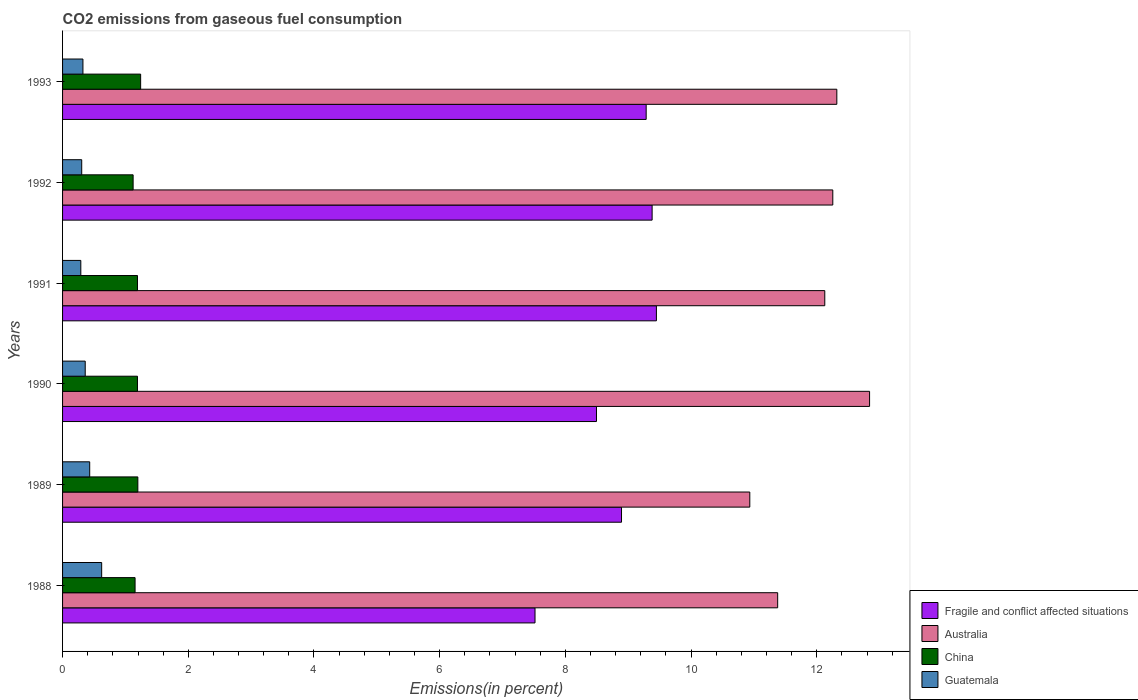How many groups of bars are there?
Provide a short and direct response. 6. Are the number of bars per tick equal to the number of legend labels?
Keep it short and to the point. Yes. How many bars are there on the 3rd tick from the top?
Ensure brevity in your answer.  4. In how many cases, is the number of bars for a given year not equal to the number of legend labels?
Ensure brevity in your answer.  0. What is the total CO2 emitted in Fragile and conflict affected situations in 1991?
Keep it short and to the point. 9.45. Across all years, what is the maximum total CO2 emitted in Guatemala?
Ensure brevity in your answer.  0.62. Across all years, what is the minimum total CO2 emitted in Australia?
Keep it short and to the point. 10.93. In which year was the total CO2 emitted in Guatemala maximum?
Ensure brevity in your answer.  1988. What is the total total CO2 emitted in Fragile and conflict affected situations in the graph?
Provide a short and direct response. 53.02. What is the difference between the total CO2 emitted in China in 1989 and that in 1993?
Give a very brief answer. -0.04. What is the difference between the total CO2 emitted in Australia in 1988 and the total CO2 emitted in Guatemala in 1989?
Make the answer very short. 10.95. What is the average total CO2 emitted in Guatemala per year?
Provide a short and direct response. 0.39. In the year 1989, what is the difference between the total CO2 emitted in China and total CO2 emitted in Guatemala?
Keep it short and to the point. 0.77. What is the ratio of the total CO2 emitted in Fragile and conflict affected situations in 1989 to that in 1991?
Give a very brief answer. 0.94. Is the difference between the total CO2 emitted in China in 1991 and 1992 greater than the difference between the total CO2 emitted in Guatemala in 1991 and 1992?
Offer a very short reply. Yes. What is the difference between the highest and the second highest total CO2 emitted in Fragile and conflict affected situations?
Provide a short and direct response. 0.07. What is the difference between the highest and the lowest total CO2 emitted in China?
Keep it short and to the point. 0.12. In how many years, is the total CO2 emitted in Fragile and conflict affected situations greater than the average total CO2 emitted in Fragile and conflict affected situations taken over all years?
Ensure brevity in your answer.  4. Is it the case that in every year, the sum of the total CO2 emitted in Australia and total CO2 emitted in Guatemala is greater than the sum of total CO2 emitted in Fragile and conflict affected situations and total CO2 emitted in China?
Provide a succinct answer. Yes. What does the 4th bar from the top in 1988 represents?
Give a very brief answer. Fragile and conflict affected situations. What does the 4th bar from the bottom in 1988 represents?
Make the answer very short. Guatemala. Is it the case that in every year, the sum of the total CO2 emitted in Fragile and conflict affected situations and total CO2 emitted in China is greater than the total CO2 emitted in Guatemala?
Provide a succinct answer. Yes. Are all the bars in the graph horizontal?
Your answer should be very brief. Yes. How many years are there in the graph?
Provide a succinct answer. 6. What is the difference between two consecutive major ticks on the X-axis?
Give a very brief answer. 2. Does the graph contain any zero values?
Keep it short and to the point. No. Does the graph contain grids?
Offer a very short reply. No. How many legend labels are there?
Provide a short and direct response. 4. How are the legend labels stacked?
Ensure brevity in your answer.  Vertical. What is the title of the graph?
Ensure brevity in your answer.  CO2 emissions from gaseous fuel consumption. What is the label or title of the X-axis?
Keep it short and to the point. Emissions(in percent). What is the Emissions(in percent) of Fragile and conflict affected situations in 1988?
Offer a very short reply. 7.52. What is the Emissions(in percent) in Australia in 1988?
Make the answer very short. 11.38. What is the Emissions(in percent) in China in 1988?
Offer a terse response. 1.15. What is the Emissions(in percent) of Guatemala in 1988?
Keep it short and to the point. 0.62. What is the Emissions(in percent) in Fragile and conflict affected situations in 1989?
Offer a very short reply. 8.89. What is the Emissions(in percent) in Australia in 1989?
Your answer should be compact. 10.93. What is the Emissions(in percent) of China in 1989?
Ensure brevity in your answer.  1.2. What is the Emissions(in percent) of Guatemala in 1989?
Keep it short and to the point. 0.43. What is the Emissions(in percent) of Fragile and conflict affected situations in 1990?
Make the answer very short. 8.49. What is the Emissions(in percent) of Australia in 1990?
Make the answer very short. 12.84. What is the Emissions(in percent) of China in 1990?
Your answer should be very brief. 1.19. What is the Emissions(in percent) of Guatemala in 1990?
Provide a short and direct response. 0.36. What is the Emissions(in percent) in Fragile and conflict affected situations in 1991?
Ensure brevity in your answer.  9.45. What is the Emissions(in percent) of Australia in 1991?
Keep it short and to the point. 12.13. What is the Emissions(in percent) in China in 1991?
Provide a short and direct response. 1.19. What is the Emissions(in percent) of Guatemala in 1991?
Keep it short and to the point. 0.29. What is the Emissions(in percent) in Fragile and conflict affected situations in 1992?
Offer a very short reply. 9.38. What is the Emissions(in percent) in Australia in 1992?
Offer a very short reply. 12.25. What is the Emissions(in percent) of China in 1992?
Your response must be concise. 1.12. What is the Emissions(in percent) in Guatemala in 1992?
Make the answer very short. 0.3. What is the Emissions(in percent) in Fragile and conflict affected situations in 1993?
Provide a short and direct response. 9.28. What is the Emissions(in percent) in Australia in 1993?
Make the answer very short. 12.32. What is the Emissions(in percent) in China in 1993?
Your answer should be compact. 1.24. What is the Emissions(in percent) in Guatemala in 1993?
Ensure brevity in your answer.  0.32. Across all years, what is the maximum Emissions(in percent) of Fragile and conflict affected situations?
Make the answer very short. 9.45. Across all years, what is the maximum Emissions(in percent) in Australia?
Your answer should be compact. 12.84. Across all years, what is the maximum Emissions(in percent) in China?
Make the answer very short. 1.24. Across all years, what is the maximum Emissions(in percent) of Guatemala?
Your answer should be very brief. 0.62. Across all years, what is the minimum Emissions(in percent) of Fragile and conflict affected situations?
Offer a terse response. 7.52. Across all years, what is the minimum Emissions(in percent) of Australia?
Offer a very short reply. 10.93. Across all years, what is the minimum Emissions(in percent) of China?
Make the answer very short. 1.12. Across all years, what is the minimum Emissions(in percent) of Guatemala?
Keep it short and to the point. 0.29. What is the total Emissions(in percent) of Fragile and conflict affected situations in the graph?
Provide a succinct answer. 53.02. What is the total Emissions(in percent) of Australia in the graph?
Offer a terse response. 71.85. What is the total Emissions(in percent) of China in the graph?
Your answer should be compact. 7.1. What is the total Emissions(in percent) in Guatemala in the graph?
Provide a succinct answer. 2.33. What is the difference between the Emissions(in percent) in Fragile and conflict affected situations in 1988 and that in 1989?
Provide a short and direct response. -1.38. What is the difference between the Emissions(in percent) in Australia in 1988 and that in 1989?
Make the answer very short. 0.44. What is the difference between the Emissions(in percent) in China in 1988 and that in 1989?
Your answer should be compact. -0.04. What is the difference between the Emissions(in percent) in Guatemala in 1988 and that in 1989?
Give a very brief answer. 0.19. What is the difference between the Emissions(in percent) of Fragile and conflict affected situations in 1988 and that in 1990?
Offer a terse response. -0.98. What is the difference between the Emissions(in percent) in Australia in 1988 and that in 1990?
Your answer should be very brief. -1.46. What is the difference between the Emissions(in percent) in China in 1988 and that in 1990?
Offer a very short reply. -0.04. What is the difference between the Emissions(in percent) of Guatemala in 1988 and that in 1990?
Provide a short and direct response. 0.26. What is the difference between the Emissions(in percent) of Fragile and conflict affected situations in 1988 and that in 1991?
Your response must be concise. -1.93. What is the difference between the Emissions(in percent) in Australia in 1988 and that in 1991?
Make the answer very short. -0.75. What is the difference between the Emissions(in percent) in China in 1988 and that in 1991?
Give a very brief answer. -0.04. What is the difference between the Emissions(in percent) of Guatemala in 1988 and that in 1991?
Provide a short and direct response. 0.33. What is the difference between the Emissions(in percent) in Fragile and conflict affected situations in 1988 and that in 1992?
Offer a very short reply. -1.86. What is the difference between the Emissions(in percent) in Australia in 1988 and that in 1992?
Your response must be concise. -0.88. What is the difference between the Emissions(in percent) in China in 1988 and that in 1992?
Give a very brief answer. 0.03. What is the difference between the Emissions(in percent) of Guatemala in 1988 and that in 1992?
Provide a short and direct response. 0.32. What is the difference between the Emissions(in percent) in Fragile and conflict affected situations in 1988 and that in 1993?
Your answer should be very brief. -1.77. What is the difference between the Emissions(in percent) in Australia in 1988 and that in 1993?
Provide a succinct answer. -0.94. What is the difference between the Emissions(in percent) in China in 1988 and that in 1993?
Your answer should be compact. -0.09. What is the difference between the Emissions(in percent) of Guatemala in 1988 and that in 1993?
Provide a succinct answer. 0.3. What is the difference between the Emissions(in percent) of Fragile and conflict affected situations in 1989 and that in 1990?
Your answer should be compact. 0.4. What is the difference between the Emissions(in percent) in Australia in 1989 and that in 1990?
Your answer should be very brief. -1.91. What is the difference between the Emissions(in percent) of China in 1989 and that in 1990?
Offer a very short reply. 0.01. What is the difference between the Emissions(in percent) of Guatemala in 1989 and that in 1990?
Your response must be concise. 0.07. What is the difference between the Emissions(in percent) in Fragile and conflict affected situations in 1989 and that in 1991?
Your answer should be very brief. -0.56. What is the difference between the Emissions(in percent) in Australia in 1989 and that in 1991?
Your response must be concise. -1.19. What is the difference between the Emissions(in percent) in China in 1989 and that in 1991?
Your answer should be very brief. 0.01. What is the difference between the Emissions(in percent) in Guatemala in 1989 and that in 1991?
Your answer should be compact. 0.14. What is the difference between the Emissions(in percent) in Fragile and conflict affected situations in 1989 and that in 1992?
Keep it short and to the point. -0.49. What is the difference between the Emissions(in percent) in Australia in 1989 and that in 1992?
Give a very brief answer. -1.32. What is the difference between the Emissions(in percent) of China in 1989 and that in 1992?
Your response must be concise. 0.07. What is the difference between the Emissions(in percent) in Guatemala in 1989 and that in 1992?
Your answer should be very brief. 0.13. What is the difference between the Emissions(in percent) of Fragile and conflict affected situations in 1989 and that in 1993?
Offer a terse response. -0.39. What is the difference between the Emissions(in percent) of Australia in 1989 and that in 1993?
Your answer should be very brief. -1.38. What is the difference between the Emissions(in percent) of China in 1989 and that in 1993?
Give a very brief answer. -0.04. What is the difference between the Emissions(in percent) in Guatemala in 1989 and that in 1993?
Your answer should be very brief. 0.11. What is the difference between the Emissions(in percent) of Fragile and conflict affected situations in 1990 and that in 1991?
Provide a short and direct response. -0.95. What is the difference between the Emissions(in percent) of Australia in 1990 and that in 1991?
Ensure brevity in your answer.  0.71. What is the difference between the Emissions(in percent) in China in 1990 and that in 1991?
Your answer should be compact. -0. What is the difference between the Emissions(in percent) in Guatemala in 1990 and that in 1991?
Make the answer very short. 0.07. What is the difference between the Emissions(in percent) of Fragile and conflict affected situations in 1990 and that in 1992?
Provide a succinct answer. -0.89. What is the difference between the Emissions(in percent) of Australia in 1990 and that in 1992?
Your response must be concise. 0.59. What is the difference between the Emissions(in percent) of China in 1990 and that in 1992?
Provide a short and direct response. 0.07. What is the difference between the Emissions(in percent) in Guatemala in 1990 and that in 1992?
Give a very brief answer. 0.06. What is the difference between the Emissions(in percent) in Fragile and conflict affected situations in 1990 and that in 1993?
Provide a short and direct response. -0.79. What is the difference between the Emissions(in percent) of Australia in 1990 and that in 1993?
Offer a terse response. 0.52. What is the difference between the Emissions(in percent) of China in 1990 and that in 1993?
Make the answer very short. -0.05. What is the difference between the Emissions(in percent) of Guatemala in 1990 and that in 1993?
Offer a terse response. 0.04. What is the difference between the Emissions(in percent) in Fragile and conflict affected situations in 1991 and that in 1992?
Offer a terse response. 0.07. What is the difference between the Emissions(in percent) of Australia in 1991 and that in 1992?
Your answer should be compact. -0.13. What is the difference between the Emissions(in percent) of China in 1991 and that in 1992?
Your answer should be compact. 0.07. What is the difference between the Emissions(in percent) of Guatemala in 1991 and that in 1992?
Offer a very short reply. -0.01. What is the difference between the Emissions(in percent) in Fragile and conflict affected situations in 1991 and that in 1993?
Your response must be concise. 0.16. What is the difference between the Emissions(in percent) of Australia in 1991 and that in 1993?
Keep it short and to the point. -0.19. What is the difference between the Emissions(in percent) of China in 1991 and that in 1993?
Offer a terse response. -0.05. What is the difference between the Emissions(in percent) of Guatemala in 1991 and that in 1993?
Your response must be concise. -0.03. What is the difference between the Emissions(in percent) in Fragile and conflict affected situations in 1992 and that in 1993?
Your response must be concise. 0.09. What is the difference between the Emissions(in percent) in Australia in 1992 and that in 1993?
Keep it short and to the point. -0.06. What is the difference between the Emissions(in percent) in China in 1992 and that in 1993?
Your answer should be compact. -0.12. What is the difference between the Emissions(in percent) of Guatemala in 1992 and that in 1993?
Your answer should be very brief. -0.02. What is the difference between the Emissions(in percent) of Fragile and conflict affected situations in 1988 and the Emissions(in percent) of Australia in 1989?
Give a very brief answer. -3.42. What is the difference between the Emissions(in percent) in Fragile and conflict affected situations in 1988 and the Emissions(in percent) in China in 1989?
Offer a terse response. 6.32. What is the difference between the Emissions(in percent) in Fragile and conflict affected situations in 1988 and the Emissions(in percent) in Guatemala in 1989?
Ensure brevity in your answer.  7.08. What is the difference between the Emissions(in percent) of Australia in 1988 and the Emissions(in percent) of China in 1989?
Offer a very short reply. 10.18. What is the difference between the Emissions(in percent) of Australia in 1988 and the Emissions(in percent) of Guatemala in 1989?
Offer a terse response. 10.95. What is the difference between the Emissions(in percent) of China in 1988 and the Emissions(in percent) of Guatemala in 1989?
Your answer should be very brief. 0.72. What is the difference between the Emissions(in percent) in Fragile and conflict affected situations in 1988 and the Emissions(in percent) in Australia in 1990?
Your answer should be compact. -5.32. What is the difference between the Emissions(in percent) in Fragile and conflict affected situations in 1988 and the Emissions(in percent) in China in 1990?
Keep it short and to the point. 6.32. What is the difference between the Emissions(in percent) of Fragile and conflict affected situations in 1988 and the Emissions(in percent) of Guatemala in 1990?
Ensure brevity in your answer.  7.16. What is the difference between the Emissions(in percent) in Australia in 1988 and the Emissions(in percent) in China in 1990?
Provide a succinct answer. 10.19. What is the difference between the Emissions(in percent) in Australia in 1988 and the Emissions(in percent) in Guatemala in 1990?
Offer a very short reply. 11.02. What is the difference between the Emissions(in percent) of China in 1988 and the Emissions(in percent) of Guatemala in 1990?
Your response must be concise. 0.79. What is the difference between the Emissions(in percent) in Fragile and conflict affected situations in 1988 and the Emissions(in percent) in Australia in 1991?
Give a very brief answer. -4.61. What is the difference between the Emissions(in percent) in Fragile and conflict affected situations in 1988 and the Emissions(in percent) in China in 1991?
Give a very brief answer. 6.32. What is the difference between the Emissions(in percent) in Fragile and conflict affected situations in 1988 and the Emissions(in percent) in Guatemala in 1991?
Your answer should be very brief. 7.23. What is the difference between the Emissions(in percent) of Australia in 1988 and the Emissions(in percent) of China in 1991?
Make the answer very short. 10.19. What is the difference between the Emissions(in percent) of Australia in 1988 and the Emissions(in percent) of Guatemala in 1991?
Your response must be concise. 11.09. What is the difference between the Emissions(in percent) of China in 1988 and the Emissions(in percent) of Guatemala in 1991?
Provide a succinct answer. 0.86. What is the difference between the Emissions(in percent) of Fragile and conflict affected situations in 1988 and the Emissions(in percent) of Australia in 1992?
Provide a short and direct response. -4.74. What is the difference between the Emissions(in percent) in Fragile and conflict affected situations in 1988 and the Emissions(in percent) in China in 1992?
Give a very brief answer. 6.39. What is the difference between the Emissions(in percent) of Fragile and conflict affected situations in 1988 and the Emissions(in percent) of Guatemala in 1992?
Offer a very short reply. 7.21. What is the difference between the Emissions(in percent) of Australia in 1988 and the Emissions(in percent) of China in 1992?
Offer a terse response. 10.25. What is the difference between the Emissions(in percent) in Australia in 1988 and the Emissions(in percent) in Guatemala in 1992?
Provide a short and direct response. 11.07. What is the difference between the Emissions(in percent) in China in 1988 and the Emissions(in percent) in Guatemala in 1992?
Provide a short and direct response. 0.85. What is the difference between the Emissions(in percent) in Fragile and conflict affected situations in 1988 and the Emissions(in percent) in Australia in 1993?
Give a very brief answer. -4.8. What is the difference between the Emissions(in percent) of Fragile and conflict affected situations in 1988 and the Emissions(in percent) of China in 1993?
Your response must be concise. 6.27. What is the difference between the Emissions(in percent) of Fragile and conflict affected situations in 1988 and the Emissions(in percent) of Guatemala in 1993?
Your response must be concise. 7.19. What is the difference between the Emissions(in percent) in Australia in 1988 and the Emissions(in percent) in China in 1993?
Ensure brevity in your answer.  10.13. What is the difference between the Emissions(in percent) of Australia in 1988 and the Emissions(in percent) of Guatemala in 1993?
Provide a succinct answer. 11.05. What is the difference between the Emissions(in percent) of China in 1988 and the Emissions(in percent) of Guatemala in 1993?
Make the answer very short. 0.83. What is the difference between the Emissions(in percent) of Fragile and conflict affected situations in 1989 and the Emissions(in percent) of Australia in 1990?
Give a very brief answer. -3.95. What is the difference between the Emissions(in percent) of Fragile and conflict affected situations in 1989 and the Emissions(in percent) of China in 1990?
Your answer should be very brief. 7.7. What is the difference between the Emissions(in percent) in Fragile and conflict affected situations in 1989 and the Emissions(in percent) in Guatemala in 1990?
Make the answer very short. 8.53. What is the difference between the Emissions(in percent) of Australia in 1989 and the Emissions(in percent) of China in 1990?
Make the answer very short. 9.74. What is the difference between the Emissions(in percent) of Australia in 1989 and the Emissions(in percent) of Guatemala in 1990?
Your answer should be very brief. 10.57. What is the difference between the Emissions(in percent) of China in 1989 and the Emissions(in percent) of Guatemala in 1990?
Offer a terse response. 0.84. What is the difference between the Emissions(in percent) in Fragile and conflict affected situations in 1989 and the Emissions(in percent) in Australia in 1991?
Provide a short and direct response. -3.23. What is the difference between the Emissions(in percent) in Fragile and conflict affected situations in 1989 and the Emissions(in percent) in China in 1991?
Provide a succinct answer. 7.7. What is the difference between the Emissions(in percent) of Fragile and conflict affected situations in 1989 and the Emissions(in percent) of Guatemala in 1991?
Provide a succinct answer. 8.6. What is the difference between the Emissions(in percent) of Australia in 1989 and the Emissions(in percent) of China in 1991?
Keep it short and to the point. 9.74. What is the difference between the Emissions(in percent) of Australia in 1989 and the Emissions(in percent) of Guatemala in 1991?
Offer a terse response. 10.64. What is the difference between the Emissions(in percent) in China in 1989 and the Emissions(in percent) in Guatemala in 1991?
Your answer should be very brief. 0.91. What is the difference between the Emissions(in percent) in Fragile and conflict affected situations in 1989 and the Emissions(in percent) in Australia in 1992?
Ensure brevity in your answer.  -3.36. What is the difference between the Emissions(in percent) in Fragile and conflict affected situations in 1989 and the Emissions(in percent) in China in 1992?
Your answer should be very brief. 7.77. What is the difference between the Emissions(in percent) of Fragile and conflict affected situations in 1989 and the Emissions(in percent) of Guatemala in 1992?
Offer a very short reply. 8.59. What is the difference between the Emissions(in percent) of Australia in 1989 and the Emissions(in percent) of China in 1992?
Give a very brief answer. 9.81. What is the difference between the Emissions(in percent) of Australia in 1989 and the Emissions(in percent) of Guatemala in 1992?
Provide a succinct answer. 10.63. What is the difference between the Emissions(in percent) of China in 1989 and the Emissions(in percent) of Guatemala in 1992?
Give a very brief answer. 0.89. What is the difference between the Emissions(in percent) in Fragile and conflict affected situations in 1989 and the Emissions(in percent) in Australia in 1993?
Offer a very short reply. -3.43. What is the difference between the Emissions(in percent) of Fragile and conflict affected situations in 1989 and the Emissions(in percent) of China in 1993?
Ensure brevity in your answer.  7.65. What is the difference between the Emissions(in percent) in Fragile and conflict affected situations in 1989 and the Emissions(in percent) in Guatemala in 1993?
Offer a terse response. 8.57. What is the difference between the Emissions(in percent) in Australia in 1989 and the Emissions(in percent) in China in 1993?
Your response must be concise. 9.69. What is the difference between the Emissions(in percent) of Australia in 1989 and the Emissions(in percent) of Guatemala in 1993?
Your answer should be compact. 10.61. What is the difference between the Emissions(in percent) in China in 1989 and the Emissions(in percent) in Guatemala in 1993?
Ensure brevity in your answer.  0.87. What is the difference between the Emissions(in percent) of Fragile and conflict affected situations in 1990 and the Emissions(in percent) of Australia in 1991?
Your response must be concise. -3.63. What is the difference between the Emissions(in percent) in Fragile and conflict affected situations in 1990 and the Emissions(in percent) in China in 1991?
Offer a very short reply. 7.3. What is the difference between the Emissions(in percent) in Fragile and conflict affected situations in 1990 and the Emissions(in percent) in Guatemala in 1991?
Offer a very short reply. 8.2. What is the difference between the Emissions(in percent) of Australia in 1990 and the Emissions(in percent) of China in 1991?
Your answer should be very brief. 11.65. What is the difference between the Emissions(in percent) of Australia in 1990 and the Emissions(in percent) of Guatemala in 1991?
Your answer should be very brief. 12.55. What is the difference between the Emissions(in percent) of China in 1990 and the Emissions(in percent) of Guatemala in 1991?
Offer a terse response. 0.9. What is the difference between the Emissions(in percent) in Fragile and conflict affected situations in 1990 and the Emissions(in percent) in Australia in 1992?
Ensure brevity in your answer.  -3.76. What is the difference between the Emissions(in percent) in Fragile and conflict affected situations in 1990 and the Emissions(in percent) in China in 1992?
Your answer should be very brief. 7.37. What is the difference between the Emissions(in percent) of Fragile and conflict affected situations in 1990 and the Emissions(in percent) of Guatemala in 1992?
Make the answer very short. 8.19. What is the difference between the Emissions(in percent) in Australia in 1990 and the Emissions(in percent) in China in 1992?
Give a very brief answer. 11.72. What is the difference between the Emissions(in percent) in Australia in 1990 and the Emissions(in percent) in Guatemala in 1992?
Your response must be concise. 12.53. What is the difference between the Emissions(in percent) of China in 1990 and the Emissions(in percent) of Guatemala in 1992?
Ensure brevity in your answer.  0.89. What is the difference between the Emissions(in percent) of Fragile and conflict affected situations in 1990 and the Emissions(in percent) of Australia in 1993?
Give a very brief answer. -3.82. What is the difference between the Emissions(in percent) in Fragile and conflict affected situations in 1990 and the Emissions(in percent) in China in 1993?
Keep it short and to the point. 7.25. What is the difference between the Emissions(in percent) in Fragile and conflict affected situations in 1990 and the Emissions(in percent) in Guatemala in 1993?
Offer a very short reply. 8.17. What is the difference between the Emissions(in percent) of Australia in 1990 and the Emissions(in percent) of China in 1993?
Offer a very short reply. 11.6. What is the difference between the Emissions(in percent) of Australia in 1990 and the Emissions(in percent) of Guatemala in 1993?
Give a very brief answer. 12.52. What is the difference between the Emissions(in percent) of China in 1990 and the Emissions(in percent) of Guatemala in 1993?
Offer a terse response. 0.87. What is the difference between the Emissions(in percent) of Fragile and conflict affected situations in 1991 and the Emissions(in percent) of Australia in 1992?
Ensure brevity in your answer.  -2.81. What is the difference between the Emissions(in percent) of Fragile and conflict affected situations in 1991 and the Emissions(in percent) of China in 1992?
Offer a very short reply. 8.33. What is the difference between the Emissions(in percent) of Fragile and conflict affected situations in 1991 and the Emissions(in percent) of Guatemala in 1992?
Ensure brevity in your answer.  9.14. What is the difference between the Emissions(in percent) in Australia in 1991 and the Emissions(in percent) in China in 1992?
Give a very brief answer. 11. What is the difference between the Emissions(in percent) in Australia in 1991 and the Emissions(in percent) in Guatemala in 1992?
Offer a terse response. 11.82. What is the difference between the Emissions(in percent) in China in 1991 and the Emissions(in percent) in Guatemala in 1992?
Give a very brief answer. 0.89. What is the difference between the Emissions(in percent) of Fragile and conflict affected situations in 1991 and the Emissions(in percent) of Australia in 1993?
Offer a very short reply. -2.87. What is the difference between the Emissions(in percent) of Fragile and conflict affected situations in 1991 and the Emissions(in percent) of China in 1993?
Ensure brevity in your answer.  8.21. What is the difference between the Emissions(in percent) of Fragile and conflict affected situations in 1991 and the Emissions(in percent) of Guatemala in 1993?
Provide a succinct answer. 9.12. What is the difference between the Emissions(in percent) in Australia in 1991 and the Emissions(in percent) in China in 1993?
Provide a short and direct response. 10.88. What is the difference between the Emissions(in percent) of Australia in 1991 and the Emissions(in percent) of Guatemala in 1993?
Make the answer very short. 11.8. What is the difference between the Emissions(in percent) in China in 1991 and the Emissions(in percent) in Guatemala in 1993?
Offer a very short reply. 0.87. What is the difference between the Emissions(in percent) in Fragile and conflict affected situations in 1992 and the Emissions(in percent) in Australia in 1993?
Provide a short and direct response. -2.94. What is the difference between the Emissions(in percent) in Fragile and conflict affected situations in 1992 and the Emissions(in percent) in China in 1993?
Make the answer very short. 8.14. What is the difference between the Emissions(in percent) of Fragile and conflict affected situations in 1992 and the Emissions(in percent) of Guatemala in 1993?
Your answer should be very brief. 9.06. What is the difference between the Emissions(in percent) of Australia in 1992 and the Emissions(in percent) of China in 1993?
Your answer should be compact. 11.01. What is the difference between the Emissions(in percent) of Australia in 1992 and the Emissions(in percent) of Guatemala in 1993?
Your response must be concise. 11.93. What is the difference between the Emissions(in percent) in China in 1992 and the Emissions(in percent) in Guatemala in 1993?
Give a very brief answer. 0.8. What is the average Emissions(in percent) in Fragile and conflict affected situations per year?
Give a very brief answer. 8.84. What is the average Emissions(in percent) in Australia per year?
Offer a very short reply. 11.97. What is the average Emissions(in percent) in China per year?
Your response must be concise. 1.18. What is the average Emissions(in percent) in Guatemala per year?
Offer a terse response. 0.39. In the year 1988, what is the difference between the Emissions(in percent) in Fragile and conflict affected situations and Emissions(in percent) in Australia?
Your answer should be compact. -3.86. In the year 1988, what is the difference between the Emissions(in percent) of Fragile and conflict affected situations and Emissions(in percent) of China?
Your answer should be very brief. 6.36. In the year 1988, what is the difference between the Emissions(in percent) of Fragile and conflict affected situations and Emissions(in percent) of Guatemala?
Offer a very short reply. 6.89. In the year 1988, what is the difference between the Emissions(in percent) of Australia and Emissions(in percent) of China?
Offer a very short reply. 10.22. In the year 1988, what is the difference between the Emissions(in percent) of Australia and Emissions(in percent) of Guatemala?
Offer a terse response. 10.75. In the year 1988, what is the difference between the Emissions(in percent) of China and Emissions(in percent) of Guatemala?
Your answer should be very brief. 0.53. In the year 1989, what is the difference between the Emissions(in percent) of Fragile and conflict affected situations and Emissions(in percent) of Australia?
Keep it short and to the point. -2.04. In the year 1989, what is the difference between the Emissions(in percent) of Fragile and conflict affected situations and Emissions(in percent) of China?
Your answer should be very brief. 7.69. In the year 1989, what is the difference between the Emissions(in percent) of Fragile and conflict affected situations and Emissions(in percent) of Guatemala?
Offer a very short reply. 8.46. In the year 1989, what is the difference between the Emissions(in percent) in Australia and Emissions(in percent) in China?
Offer a terse response. 9.74. In the year 1989, what is the difference between the Emissions(in percent) of Australia and Emissions(in percent) of Guatemala?
Your answer should be very brief. 10.5. In the year 1989, what is the difference between the Emissions(in percent) in China and Emissions(in percent) in Guatemala?
Your answer should be compact. 0.77. In the year 1990, what is the difference between the Emissions(in percent) in Fragile and conflict affected situations and Emissions(in percent) in Australia?
Keep it short and to the point. -4.34. In the year 1990, what is the difference between the Emissions(in percent) in Fragile and conflict affected situations and Emissions(in percent) in China?
Offer a very short reply. 7.3. In the year 1990, what is the difference between the Emissions(in percent) in Fragile and conflict affected situations and Emissions(in percent) in Guatemala?
Your response must be concise. 8.13. In the year 1990, what is the difference between the Emissions(in percent) of Australia and Emissions(in percent) of China?
Offer a very short reply. 11.65. In the year 1990, what is the difference between the Emissions(in percent) in Australia and Emissions(in percent) in Guatemala?
Ensure brevity in your answer.  12.48. In the year 1990, what is the difference between the Emissions(in percent) of China and Emissions(in percent) of Guatemala?
Ensure brevity in your answer.  0.83. In the year 1991, what is the difference between the Emissions(in percent) in Fragile and conflict affected situations and Emissions(in percent) in Australia?
Your answer should be compact. -2.68. In the year 1991, what is the difference between the Emissions(in percent) in Fragile and conflict affected situations and Emissions(in percent) in China?
Keep it short and to the point. 8.26. In the year 1991, what is the difference between the Emissions(in percent) of Fragile and conflict affected situations and Emissions(in percent) of Guatemala?
Ensure brevity in your answer.  9.16. In the year 1991, what is the difference between the Emissions(in percent) of Australia and Emissions(in percent) of China?
Make the answer very short. 10.93. In the year 1991, what is the difference between the Emissions(in percent) in Australia and Emissions(in percent) in Guatemala?
Ensure brevity in your answer.  11.84. In the year 1991, what is the difference between the Emissions(in percent) in China and Emissions(in percent) in Guatemala?
Your answer should be compact. 0.9. In the year 1992, what is the difference between the Emissions(in percent) in Fragile and conflict affected situations and Emissions(in percent) in Australia?
Make the answer very short. -2.87. In the year 1992, what is the difference between the Emissions(in percent) in Fragile and conflict affected situations and Emissions(in percent) in China?
Give a very brief answer. 8.26. In the year 1992, what is the difference between the Emissions(in percent) in Fragile and conflict affected situations and Emissions(in percent) in Guatemala?
Make the answer very short. 9.07. In the year 1992, what is the difference between the Emissions(in percent) in Australia and Emissions(in percent) in China?
Keep it short and to the point. 11.13. In the year 1992, what is the difference between the Emissions(in percent) in Australia and Emissions(in percent) in Guatemala?
Provide a short and direct response. 11.95. In the year 1992, what is the difference between the Emissions(in percent) of China and Emissions(in percent) of Guatemala?
Keep it short and to the point. 0.82. In the year 1993, what is the difference between the Emissions(in percent) in Fragile and conflict affected situations and Emissions(in percent) in Australia?
Give a very brief answer. -3.03. In the year 1993, what is the difference between the Emissions(in percent) of Fragile and conflict affected situations and Emissions(in percent) of China?
Give a very brief answer. 8.04. In the year 1993, what is the difference between the Emissions(in percent) of Fragile and conflict affected situations and Emissions(in percent) of Guatemala?
Offer a very short reply. 8.96. In the year 1993, what is the difference between the Emissions(in percent) of Australia and Emissions(in percent) of China?
Ensure brevity in your answer.  11.08. In the year 1993, what is the difference between the Emissions(in percent) of Australia and Emissions(in percent) of Guatemala?
Your answer should be compact. 11.99. In the year 1993, what is the difference between the Emissions(in percent) in China and Emissions(in percent) in Guatemala?
Ensure brevity in your answer.  0.92. What is the ratio of the Emissions(in percent) of Fragile and conflict affected situations in 1988 to that in 1989?
Keep it short and to the point. 0.85. What is the ratio of the Emissions(in percent) of Australia in 1988 to that in 1989?
Give a very brief answer. 1.04. What is the ratio of the Emissions(in percent) of China in 1988 to that in 1989?
Your answer should be very brief. 0.96. What is the ratio of the Emissions(in percent) of Guatemala in 1988 to that in 1989?
Your answer should be compact. 1.44. What is the ratio of the Emissions(in percent) of Fragile and conflict affected situations in 1988 to that in 1990?
Your answer should be compact. 0.88. What is the ratio of the Emissions(in percent) in Australia in 1988 to that in 1990?
Offer a terse response. 0.89. What is the ratio of the Emissions(in percent) in China in 1988 to that in 1990?
Your answer should be compact. 0.97. What is the ratio of the Emissions(in percent) of Guatemala in 1988 to that in 1990?
Keep it short and to the point. 1.73. What is the ratio of the Emissions(in percent) in Fragile and conflict affected situations in 1988 to that in 1991?
Your answer should be very brief. 0.8. What is the ratio of the Emissions(in percent) in Australia in 1988 to that in 1991?
Ensure brevity in your answer.  0.94. What is the ratio of the Emissions(in percent) in China in 1988 to that in 1991?
Keep it short and to the point. 0.97. What is the ratio of the Emissions(in percent) in Guatemala in 1988 to that in 1991?
Your answer should be compact. 2.14. What is the ratio of the Emissions(in percent) in Fragile and conflict affected situations in 1988 to that in 1992?
Keep it short and to the point. 0.8. What is the ratio of the Emissions(in percent) in Australia in 1988 to that in 1992?
Your answer should be compact. 0.93. What is the ratio of the Emissions(in percent) in China in 1988 to that in 1992?
Provide a short and direct response. 1.03. What is the ratio of the Emissions(in percent) of Guatemala in 1988 to that in 1992?
Provide a succinct answer. 2.04. What is the ratio of the Emissions(in percent) of Fragile and conflict affected situations in 1988 to that in 1993?
Provide a short and direct response. 0.81. What is the ratio of the Emissions(in percent) in Australia in 1988 to that in 1993?
Offer a very short reply. 0.92. What is the ratio of the Emissions(in percent) of China in 1988 to that in 1993?
Your response must be concise. 0.93. What is the ratio of the Emissions(in percent) of Guatemala in 1988 to that in 1993?
Provide a succinct answer. 1.92. What is the ratio of the Emissions(in percent) of Fragile and conflict affected situations in 1989 to that in 1990?
Keep it short and to the point. 1.05. What is the ratio of the Emissions(in percent) in Australia in 1989 to that in 1990?
Offer a terse response. 0.85. What is the ratio of the Emissions(in percent) in Guatemala in 1989 to that in 1990?
Your answer should be compact. 1.2. What is the ratio of the Emissions(in percent) in Fragile and conflict affected situations in 1989 to that in 1991?
Your response must be concise. 0.94. What is the ratio of the Emissions(in percent) in Australia in 1989 to that in 1991?
Your answer should be very brief. 0.9. What is the ratio of the Emissions(in percent) in China in 1989 to that in 1991?
Provide a succinct answer. 1. What is the ratio of the Emissions(in percent) in Guatemala in 1989 to that in 1991?
Offer a very short reply. 1.49. What is the ratio of the Emissions(in percent) of Fragile and conflict affected situations in 1989 to that in 1992?
Provide a succinct answer. 0.95. What is the ratio of the Emissions(in percent) of Australia in 1989 to that in 1992?
Provide a succinct answer. 0.89. What is the ratio of the Emissions(in percent) of China in 1989 to that in 1992?
Give a very brief answer. 1.07. What is the ratio of the Emissions(in percent) in Guatemala in 1989 to that in 1992?
Your answer should be compact. 1.42. What is the ratio of the Emissions(in percent) in Fragile and conflict affected situations in 1989 to that in 1993?
Provide a short and direct response. 0.96. What is the ratio of the Emissions(in percent) of Australia in 1989 to that in 1993?
Provide a succinct answer. 0.89. What is the ratio of the Emissions(in percent) of China in 1989 to that in 1993?
Your answer should be compact. 0.96. What is the ratio of the Emissions(in percent) in Guatemala in 1989 to that in 1993?
Provide a short and direct response. 1.33. What is the ratio of the Emissions(in percent) of Fragile and conflict affected situations in 1990 to that in 1991?
Ensure brevity in your answer.  0.9. What is the ratio of the Emissions(in percent) of Australia in 1990 to that in 1991?
Provide a short and direct response. 1.06. What is the ratio of the Emissions(in percent) of China in 1990 to that in 1991?
Give a very brief answer. 1. What is the ratio of the Emissions(in percent) in Guatemala in 1990 to that in 1991?
Give a very brief answer. 1.24. What is the ratio of the Emissions(in percent) in Fragile and conflict affected situations in 1990 to that in 1992?
Provide a short and direct response. 0.91. What is the ratio of the Emissions(in percent) in Australia in 1990 to that in 1992?
Your answer should be very brief. 1.05. What is the ratio of the Emissions(in percent) in China in 1990 to that in 1992?
Offer a very short reply. 1.06. What is the ratio of the Emissions(in percent) of Guatemala in 1990 to that in 1992?
Your answer should be very brief. 1.18. What is the ratio of the Emissions(in percent) in Fragile and conflict affected situations in 1990 to that in 1993?
Your response must be concise. 0.91. What is the ratio of the Emissions(in percent) of Australia in 1990 to that in 1993?
Offer a very short reply. 1.04. What is the ratio of the Emissions(in percent) in China in 1990 to that in 1993?
Make the answer very short. 0.96. What is the ratio of the Emissions(in percent) in Guatemala in 1990 to that in 1993?
Your answer should be compact. 1.11. What is the ratio of the Emissions(in percent) in Fragile and conflict affected situations in 1991 to that in 1992?
Give a very brief answer. 1.01. What is the ratio of the Emissions(in percent) in Australia in 1991 to that in 1992?
Provide a succinct answer. 0.99. What is the ratio of the Emissions(in percent) in China in 1991 to that in 1992?
Offer a very short reply. 1.06. What is the ratio of the Emissions(in percent) of Guatemala in 1991 to that in 1992?
Your answer should be compact. 0.95. What is the ratio of the Emissions(in percent) of Fragile and conflict affected situations in 1991 to that in 1993?
Your answer should be compact. 1.02. What is the ratio of the Emissions(in percent) in Australia in 1991 to that in 1993?
Offer a terse response. 0.98. What is the ratio of the Emissions(in percent) of China in 1991 to that in 1993?
Provide a succinct answer. 0.96. What is the ratio of the Emissions(in percent) of Guatemala in 1991 to that in 1993?
Give a very brief answer. 0.9. What is the ratio of the Emissions(in percent) of Fragile and conflict affected situations in 1992 to that in 1993?
Your answer should be very brief. 1.01. What is the ratio of the Emissions(in percent) of China in 1992 to that in 1993?
Give a very brief answer. 0.9. What is the ratio of the Emissions(in percent) of Guatemala in 1992 to that in 1993?
Your answer should be compact. 0.94. What is the difference between the highest and the second highest Emissions(in percent) of Fragile and conflict affected situations?
Your answer should be very brief. 0.07. What is the difference between the highest and the second highest Emissions(in percent) in Australia?
Your response must be concise. 0.52. What is the difference between the highest and the second highest Emissions(in percent) of China?
Offer a very short reply. 0.04. What is the difference between the highest and the second highest Emissions(in percent) of Guatemala?
Your answer should be compact. 0.19. What is the difference between the highest and the lowest Emissions(in percent) of Fragile and conflict affected situations?
Your answer should be very brief. 1.93. What is the difference between the highest and the lowest Emissions(in percent) of Australia?
Offer a very short reply. 1.91. What is the difference between the highest and the lowest Emissions(in percent) of China?
Keep it short and to the point. 0.12. What is the difference between the highest and the lowest Emissions(in percent) in Guatemala?
Give a very brief answer. 0.33. 